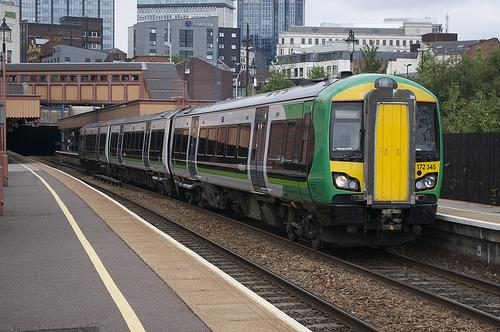Can you count the number of lights on the front of the train and describe their arrangement? There are five lights on the front of the train, likely arranged in a horizontal line or a specific pattern. Mention key elements in the picture's background, including the color of the sky and the type of buildings present. In the background, there are large buildings, some with many windows or logos, a tall skyscraper, an old-fashioned street lamp, and a blue sky. What is the description of the windows on the train, and how do they appear to be tinted? The windows on the train are almost perfectly square, and they are tinted, likely having a dark or reflective appearance. Please provide a brief and concise description of the scene in the image. A green and yellow train is on black tracks near a platform with a yellow line, while large buildings and a covered bridge are in the background, and the sky is blue. Point out the features of the train's face and describe the headlights' unique design. The front of the train looks like a face, and the headlights have an artistically wavy slant, making them unusual. What color is the train platform, and what detail can you notice about the line on its edge? The train platform is black, and it has a yellow line along its edge. What can you observe about the train's side regarding doors and their spacing? Many doors line the train's side, and they are evenly spaced. 